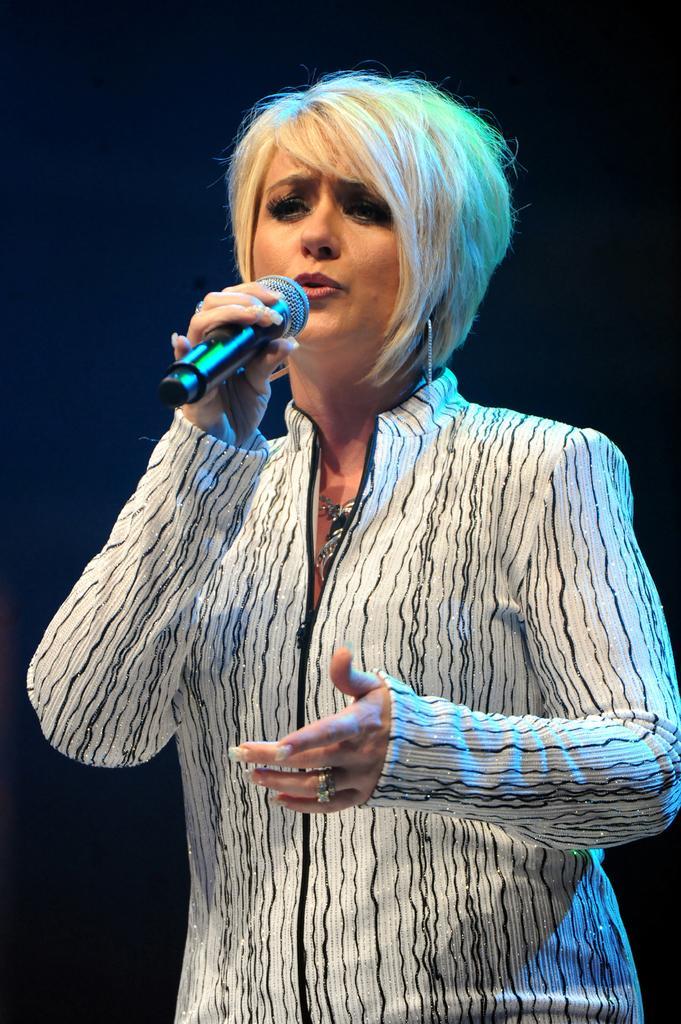How would you summarize this image in a sentence or two? In the center of the image we can see a lady standing and holding a mic in her hand. 